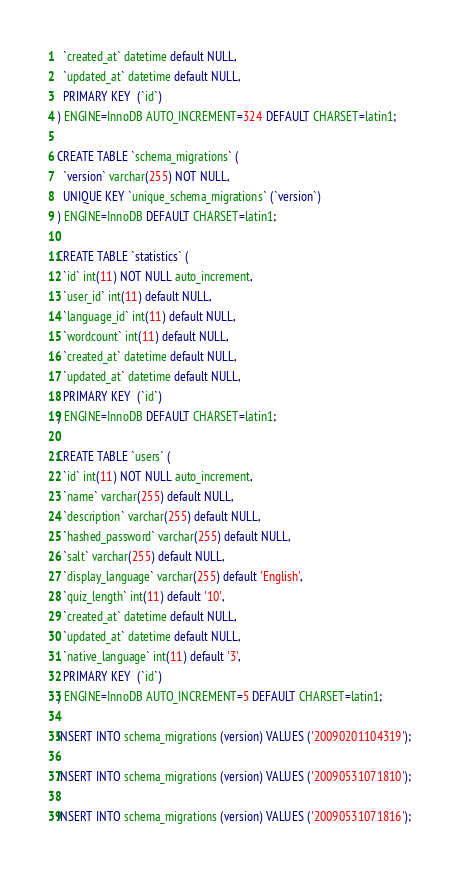Convert code to text. <code><loc_0><loc_0><loc_500><loc_500><_SQL_>  `created_at` datetime default NULL,
  `updated_at` datetime default NULL,
  PRIMARY KEY  (`id`)
) ENGINE=InnoDB AUTO_INCREMENT=324 DEFAULT CHARSET=latin1;

CREATE TABLE `schema_migrations` (
  `version` varchar(255) NOT NULL,
  UNIQUE KEY `unique_schema_migrations` (`version`)
) ENGINE=InnoDB DEFAULT CHARSET=latin1;

CREATE TABLE `statistics` (
  `id` int(11) NOT NULL auto_increment,
  `user_id` int(11) default NULL,
  `language_id` int(11) default NULL,
  `wordcount` int(11) default NULL,
  `created_at` datetime default NULL,
  `updated_at` datetime default NULL,
  PRIMARY KEY  (`id`)
) ENGINE=InnoDB DEFAULT CHARSET=latin1;

CREATE TABLE `users` (
  `id` int(11) NOT NULL auto_increment,
  `name` varchar(255) default NULL,
  `description` varchar(255) default NULL,
  `hashed_password` varchar(255) default NULL,
  `salt` varchar(255) default NULL,
  `display_language` varchar(255) default 'English',
  `quiz_length` int(11) default '10',
  `created_at` datetime default NULL,
  `updated_at` datetime default NULL,
  `native_language` int(11) default '3',
  PRIMARY KEY  (`id`)
) ENGINE=InnoDB AUTO_INCREMENT=5 DEFAULT CHARSET=latin1;

INSERT INTO schema_migrations (version) VALUES ('20090201104319');

INSERT INTO schema_migrations (version) VALUES ('20090531071810');

INSERT INTO schema_migrations (version) VALUES ('20090531071816');
</code> 